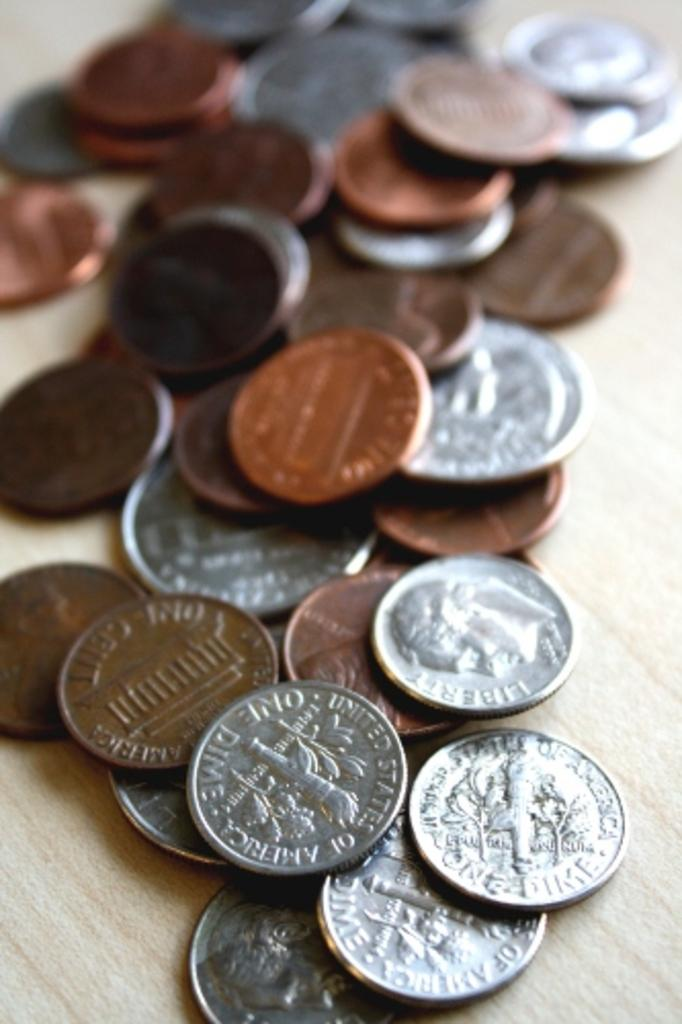Provide a one-sentence caption for the provided image. A bunch of American coins including dimes, pennies, nickels and quarters. 